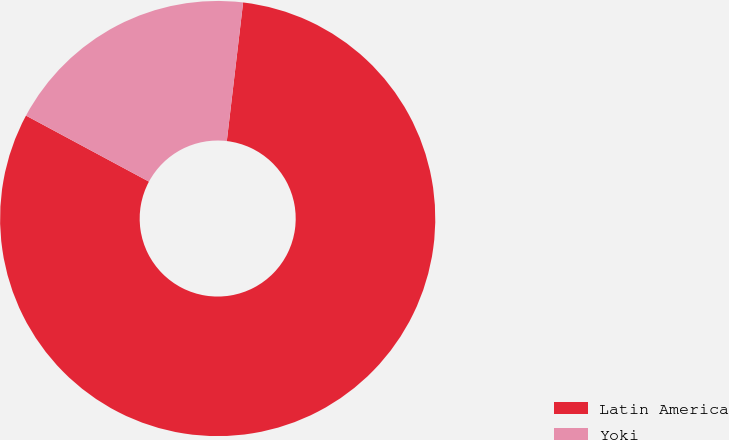Convert chart to OTSL. <chart><loc_0><loc_0><loc_500><loc_500><pie_chart><fcel>Latin America<fcel>Yoki<nl><fcel>80.98%<fcel>19.02%<nl></chart> 